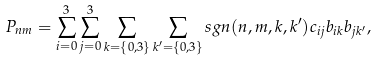<formula> <loc_0><loc_0><loc_500><loc_500>P _ { n m } = \sum _ { i = 0 } ^ { 3 } \sum _ { j = 0 } ^ { 3 } \sum _ { k = \{ 0 , 3 \} } \sum _ { k ^ { \prime } = \{ 0 , 3 \} } s g n ( n , m , k , k ^ { \prime } ) c _ { i j } b _ { i k } b _ { j k ^ { \prime } } ,</formula> 